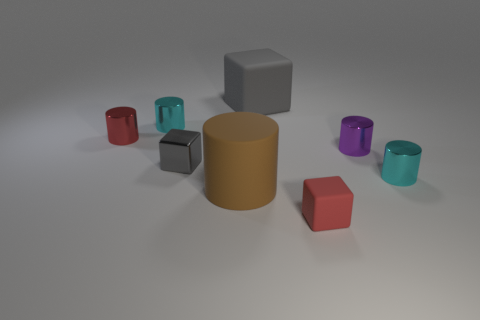Is the number of large brown rubber things behind the tiny gray thing less than the number of green balls?
Your response must be concise. No. What is the color of the big object that is in front of the small metallic cylinder that is in front of the gray object to the left of the large cylinder?
Offer a very short reply. Brown. Is there any other thing that is made of the same material as the red block?
Your answer should be compact. Yes. The red shiny thing that is the same shape as the brown thing is what size?
Make the answer very short. Small. Are there fewer small rubber cubes behind the red block than small metal cubes that are to the right of the big brown matte cylinder?
Provide a short and direct response. No. What is the shape of the thing that is in front of the gray shiny thing and behind the brown thing?
Provide a short and direct response. Cylinder. There is a purple cylinder that is the same material as the red cylinder; what size is it?
Your response must be concise. Small. There is a large cylinder; is its color the same as the matte cube behind the small matte cube?
Your response must be concise. No. There is a thing that is both in front of the purple metal cylinder and to the right of the tiny matte thing; what material is it made of?
Make the answer very short. Metal. There is another metallic block that is the same color as the big cube; what is its size?
Provide a succinct answer. Small. 